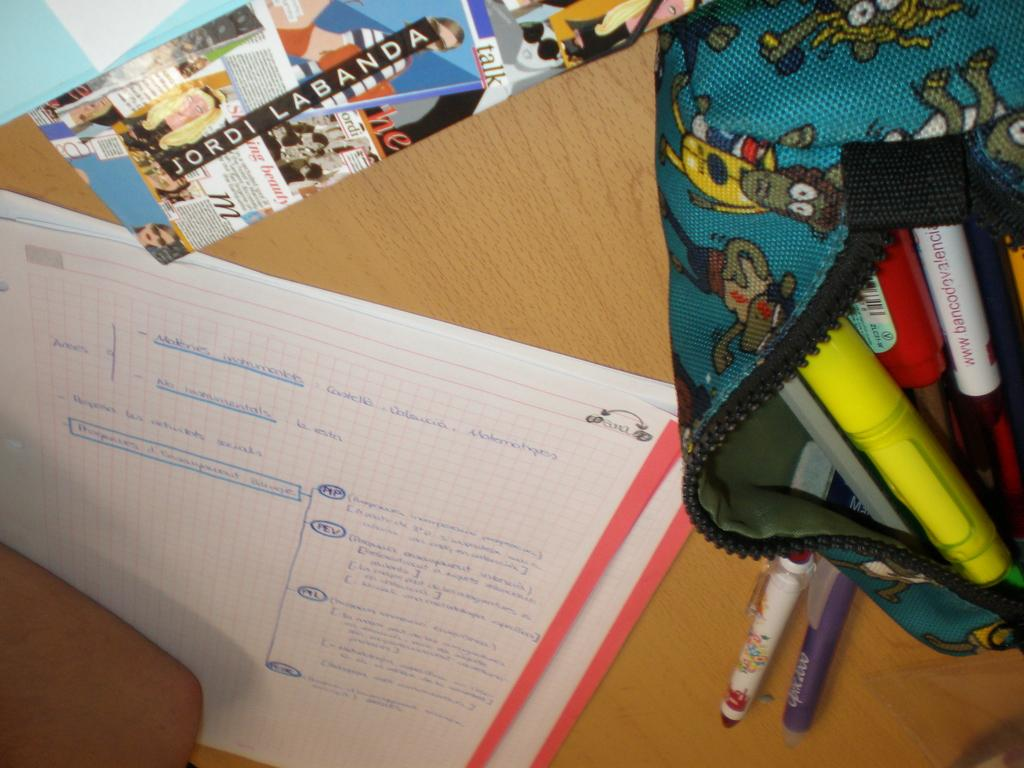<image>
Summarize the visual content of the image. Piece of paper on a desk with the word "JORDI LABANDA" on it. 